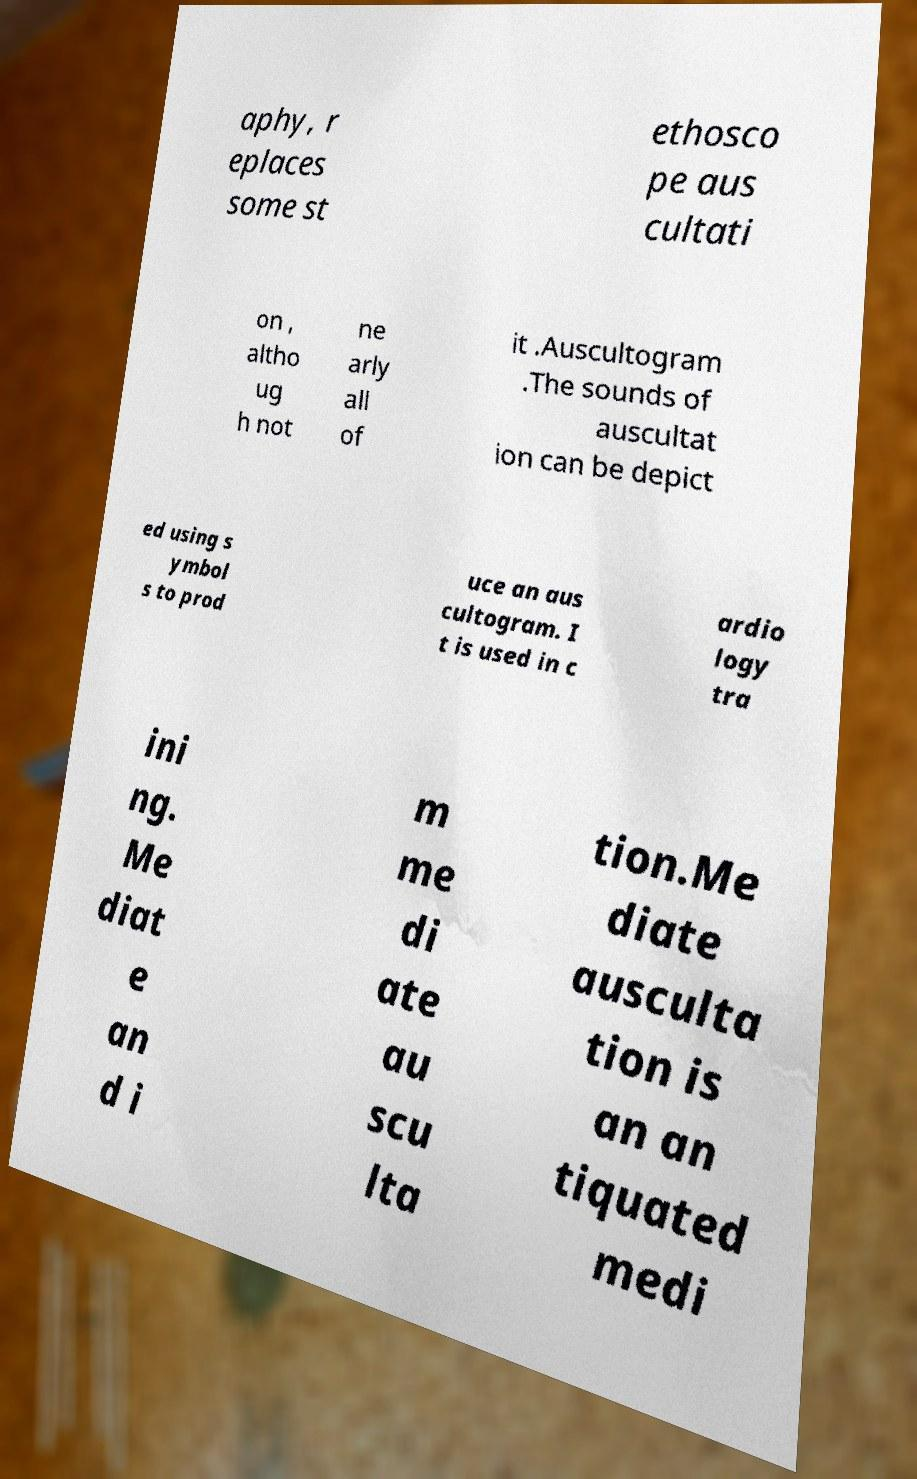Please identify and transcribe the text found in this image. aphy, r eplaces some st ethosco pe aus cultati on , altho ug h not ne arly all of it .Auscultogram .The sounds of auscultat ion can be depict ed using s ymbol s to prod uce an aus cultogram. I t is used in c ardio logy tra ini ng. Me diat e an d i m me di ate au scu lta tion.Me diate ausculta tion is an an tiquated medi 